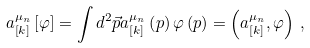<formula> <loc_0><loc_0><loc_500><loc_500>a _ { \left [ k \right ] } ^ { \mu _ { n } } \left [ \varphi \right ] = \int d ^ { 2 } \vec { p } a _ { \left [ k \right ] } ^ { \mu _ { n } } \left ( p \right ) \varphi \left ( p \right ) = \left ( a _ { \left [ k \right ] } ^ { \mu _ { n } } , \varphi \right ) \, ,</formula> 